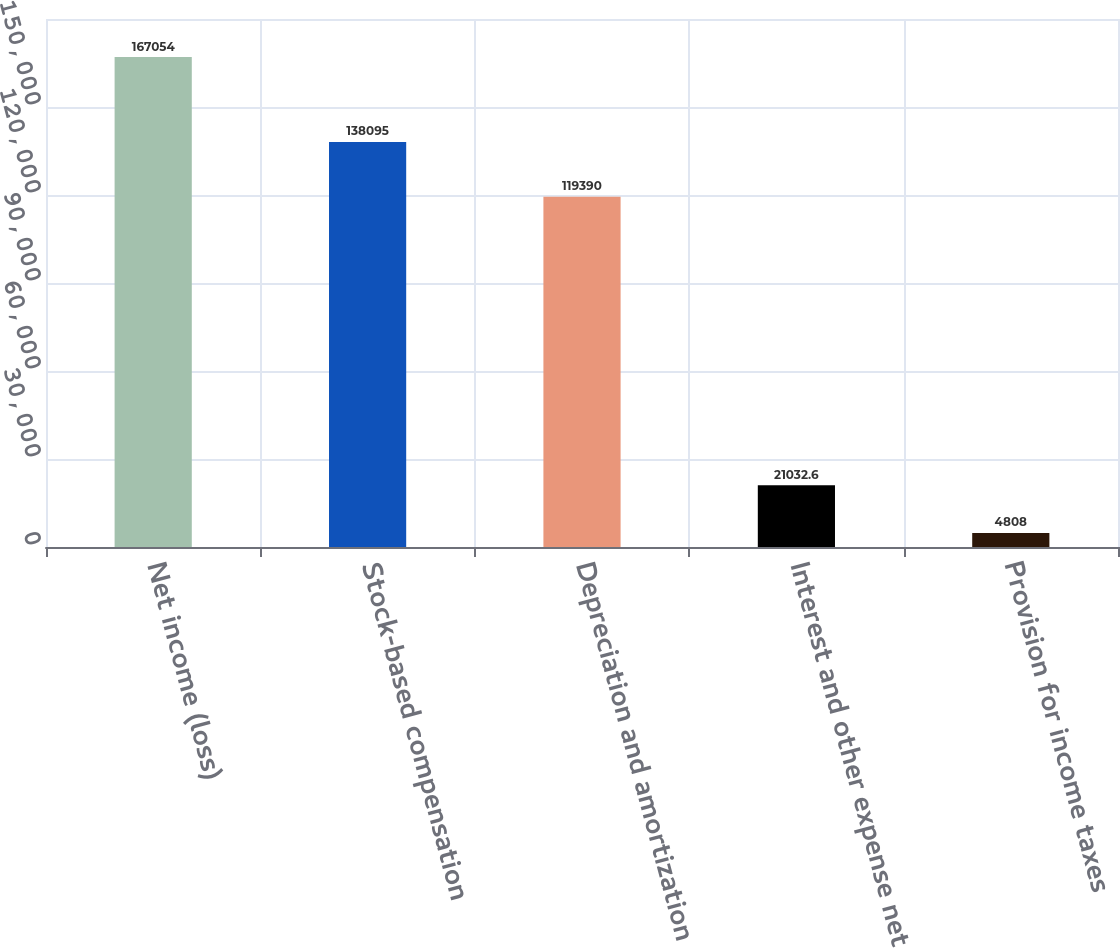Convert chart to OTSL. <chart><loc_0><loc_0><loc_500><loc_500><bar_chart><fcel>Net income (loss)<fcel>Stock-based compensation<fcel>Depreciation and amortization<fcel>Interest and other expense net<fcel>Provision for income taxes<nl><fcel>167054<fcel>138095<fcel>119390<fcel>21032.6<fcel>4808<nl></chart> 